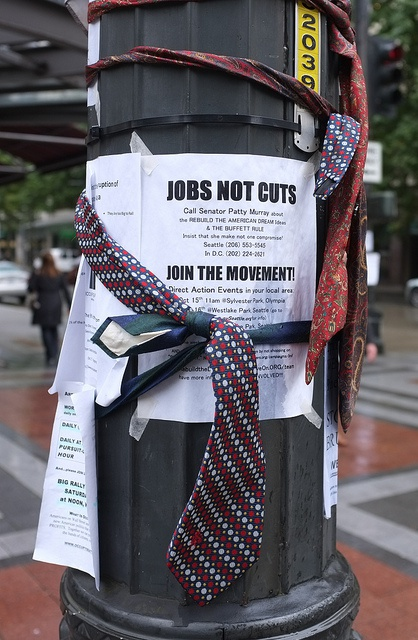Describe the objects in this image and their specific colors. I can see tie in black, maroon, navy, and gray tones, tie in black, maroon, brown, and gray tones, tie in black, gray, maroon, and brown tones, tie in black, blue, lightgray, and navy tones, and people in black, gray, and maroon tones in this image. 